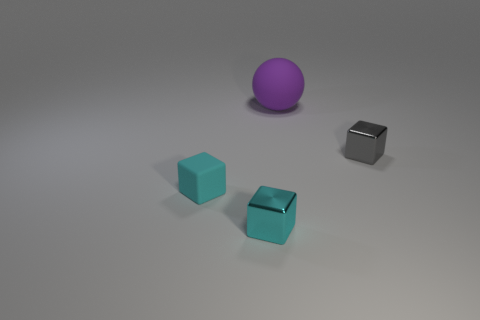Are there any other things that are the same size as the cyan matte thing?
Provide a succinct answer. Yes. Is the number of rubber objects to the right of the small cyan metallic cube greater than the number of blue rubber blocks?
Your answer should be compact. Yes. There is a gray shiny cube; are there any cyan metallic cubes in front of it?
Your answer should be very brief. Yes. Is the shape of the gray metallic object the same as the tiny cyan rubber thing?
Your response must be concise. Yes. There is a gray cube that is behind the cyan cube behind the small metallic cube in front of the small gray metallic thing; what is its size?
Your answer should be compact. Small. What is the material of the purple ball?
Your answer should be very brief. Rubber. There is a cyan metal object; is it the same shape as the tiny object that is to the right of the big object?
Your response must be concise. Yes. The thing behind the small metal thing behind the tiny metallic thing that is to the left of the matte sphere is made of what material?
Make the answer very short. Rubber. How many cyan metal cubes are there?
Provide a succinct answer. 1. What number of purple objects are either large things or tiny matte things?
Provide a short and direct response. 1. 